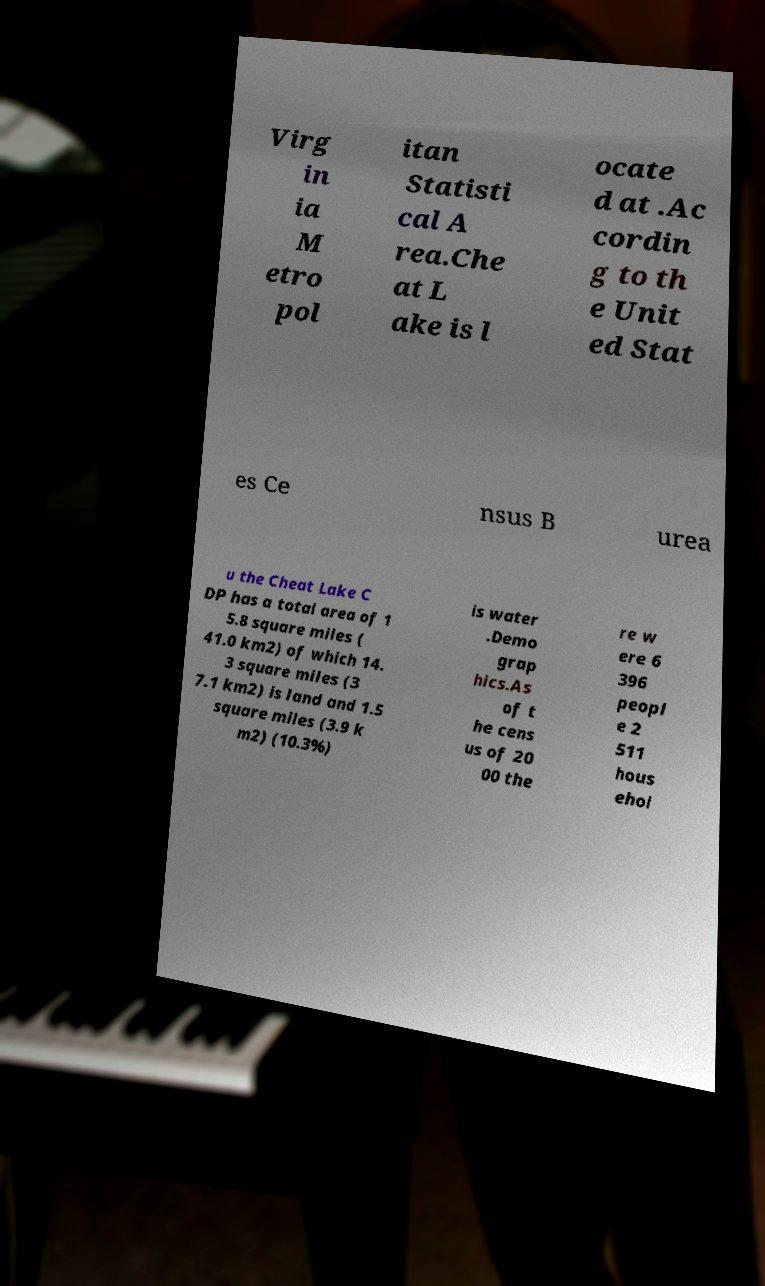What messages or text are displayed in this image? I need them in a readable, typed format. Virg in ia M etro pol itan Statisti cal A rea.Che at L ake is l ocate d at .Ac cordin g to th e Unit ed Stat es Ce nsus B urea u the Cheat Lake C DP has a total area of 1 5.8 square miles ( 41.0 km2) of which 14. 3 square miles (3 7.1 km2) is land and 1.5 square miles (3.9 k m2) (10.3%) is water .Demo grap hics.As of t he cens us of 20 00 the re w ere 6 396 peopl e 2 511 hous ehol 